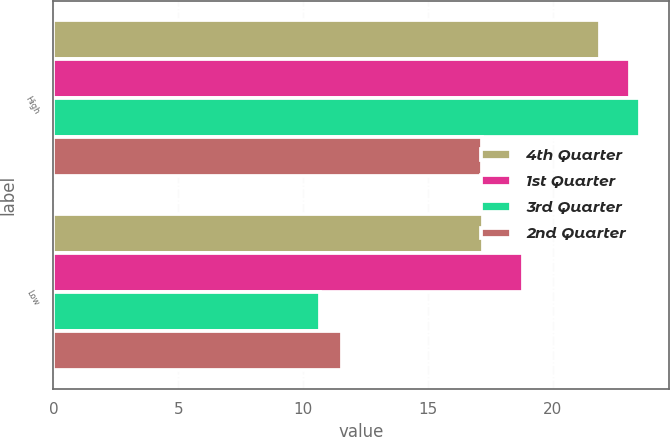Convert chart to OTSL. <chart><loc_0><loc_0><loc_500><loc_500><stacked_bar_chart><ecel><fcel>High<fcel>Low<nl><fcel>4th Quarter<fcel>21.9<fcel>17.21<nl><fcel>1st Quarter<fcel>23.09<fcel>18.82<nl><fcel>3rd Quarter<fcel>23.48<fcel>10.66<nl><fcel>2nd Quarter<fcel>17.16<fcel>11.54<nl></chart> 